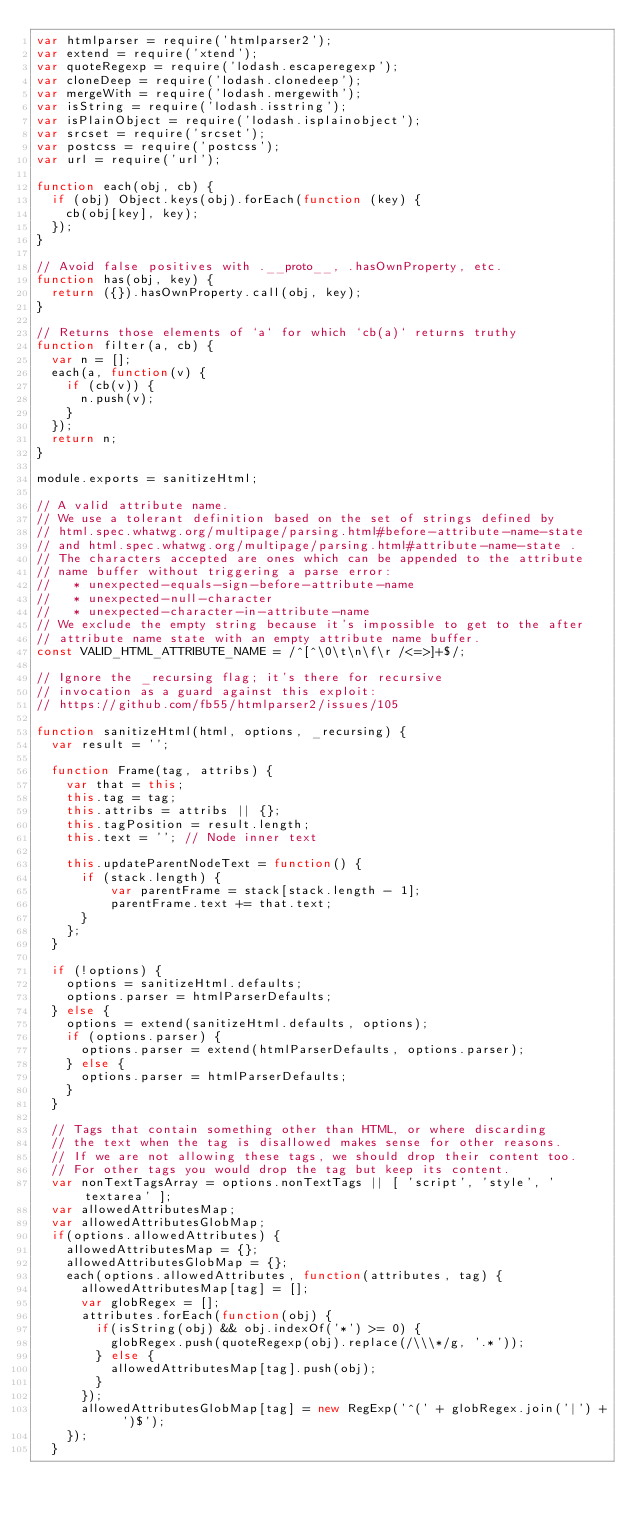<code> <loc_0><loc_0><loc_500><loc_500><_JavaScript_>var htmlparser = require('htmlparser2');
var extend = require('xtend');
var quoteRegexp = require('lodash.escaperegexp');
var cloneDeep = require('lodash.clonedeep');
var mergeWith = require('lodash.mergewith');
var isString = require('lodash.isstring');
var isPlainObject = require('lodash.isplainobject');
var srcset = require('srcset');
var postcss = require('postcss');
var url = require('url');

function each(obj, cb) {
  if (obj) Object.keys(obj).forEach(function (key) {
    cb(obj[key], key);
  });
}

// Avoid false positives with .__proto__, .hasOwnProperty, etc.
function has(obj, key) {
  return ({}).hasOwnProperty.call(obj, key);
}

// Returns those elements of `a` for which `cb(a)` returns truthy
function filter(a, cb) {
  var n = [];
  each(a, function(v) {
    if (cb(v)) {
      n.push(v);
    }
  });
  return n;
}

module.exports = sanitizeHtml;

// A valid attribute name.
// We use a tolerant definition based on the set of strings defined by
// html.spec.whatwg.org/multipage/parsing.html#before-attribute-name-state
// and html.spec.whatwg.org/multipage/parsing.html#attribute-name-state .
// The characters accepted are ones which can be appended to the attribute
// name buffer without triggering a parse error:
//   * unexpected-equals-sign-before-attribute-name
//   * unexpected-null-character
//   * unexpected-character-in-attribute-name
// We exclude the empty string because it's impossible to get to the after
// attribute name state with an empty attribute name buffer.
const VALID_HTML_ATTRIBUTE_NAME = /^[^\0\t\n\f\r /<=>]+$/;

// Ignore the _recursing flag; it's there for recursive
// invocation as a guard against this exploit:
// https://github.com/fb55/htmlparser2/issues/105

function sanitizeHtml(html, options, _recursing) {
  var result = '';

  function Frame(tag, attribs) {
    var that = this;
    this.tag = tag;
    this.attribs = attribs || {};
    this.tagPosition = result.length;
    this.text = ''; // Node inner text

    this.updateParentNodeText = function() {
      if (stack.length) {
          var parentFrame = stack[stack.length - 1];
          parentFrame.text += that.text;
      }
    };
  }

  if (!options) {
    options = sanitizeHtml.defaults;
    options.parser = htmlParserDefaults;
  } else {
    options = extend(sanitizeHtml.defaults, options);
    if (options.parser) {
      options.parser = extend(htmlParserDefaults, options.parser);
    } else {
      options.parser = htmlParserDefaults;
    }
  }

  // Tags that contain something other than HTML, or where discarding
  // the text when the tag is disallowed makes sense for other reasons.
  // If we are not allowing these tags, we should drop their content too.
  // For other tags you would drop the tag but keep its content.
  var nonTextTagsArray = options.nonTextTags || [ 'script', 'style', 'textarea' ];
  var allowedAttributesMap;
  var allowedAttributesGlobMap;
  if(options.allowedAttributes) {
    allowedAttributesMap = {};
    allowedAttributesGlobMap = {};
    each(options.allowedAttributes, function(attributes, tag) {
      allowedAttributesMap[tag] = [];
      var globRegex = [];
      attributes.forEach(function(obj) {
        if(isString(obj) && obj.indexOf('*') >= 0) {
          globRegex.push(quoteRegexp(obj).replace(/\\\*/g, '.*'));
        } else {
          allowedAttributesMap[tag].push(obj);
        }
      });
      allowedAttributesGlobMap[tag] = new RegExp('^(' + globRegex.join('|') + ')$');
    });
  }</code> 